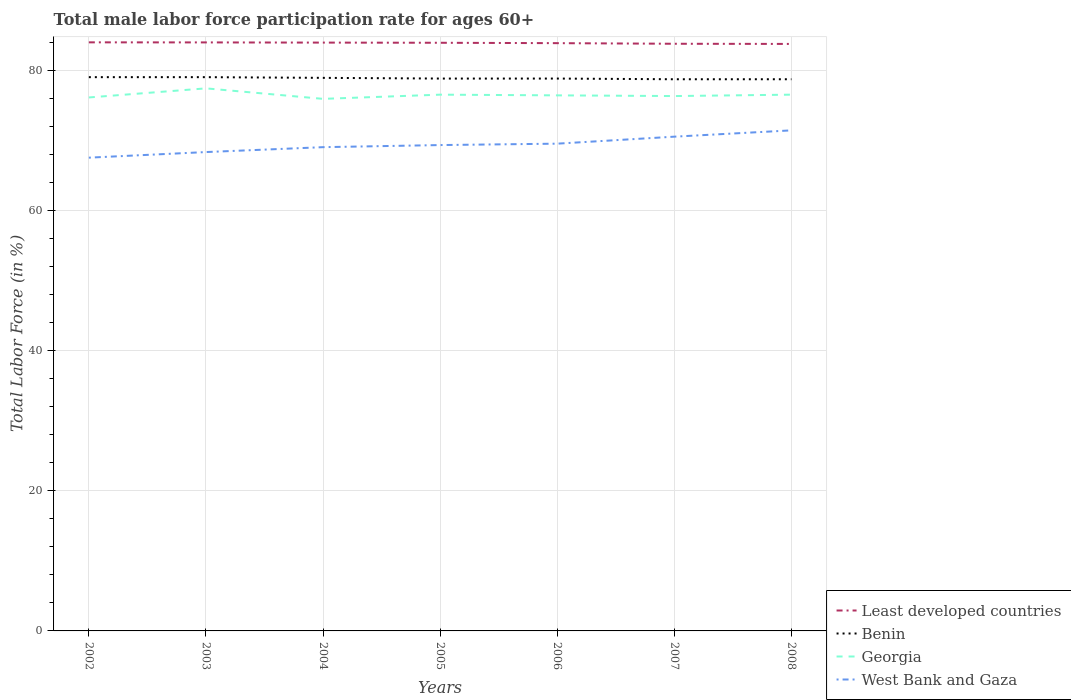Does the line corresponding to Least developed countries intersect with the line corresponding to Georgia?
Ensure brevity in your answer.  No. Across all years, what is the maximum male labor force participation rate in Georgia?
Keep it short and to the point. 76. What is the total male labor force participation rate in Georgia in the graph?
Your answer should be compact. 1.1. What is the difference between the highest and the second highest male labor force participation rate in Least developed countries?
Give a very brief answer. 0.23. What is the difference between the highest and the lowest male labor force participation rate in Georgia?
Your response must be concise. 3. Is the male labor force participation rate in Benin strictly greater than the male labor force participation rate in Least developed countries over the years?
Your answer should be very brief. Yes. How many lines are there?
Provide a short and direct response. 4. What is the difference between two consecutive major ticks on the Y-axis?
Provide a succinct answer. 20. Does the graph contain grids?
Ensure brevity in your answer.  Yes. How are the legend labels stacked?
Offer a very short reply. Vertical. What is the title of the graph?
Keep it short and to the point. Total male labor force participation rate for ages 60+. Does "Netherlands" appear as one of the legend labels in the graph?
Give a very brief answer. No. What is the label or title of the Y-axis?
Provide a succinct answer. Total Labor Force (in %). What is the Total Labor Force (in %) of Least developed countries in 2002?
Your answer should be very brief. 84.07. What is the Total Labor Force (in %) of Benin in 2002?
Your answer should be very brief. 79.1. What is the Total Labor Force (in %) of Georgia in 2002?
Ensure brevity in your answer.  76.2. What is the Total Labor Force (in %) in West Bank and Gaza in 2002?
Your answer should be very brief. 67.6. What is the Total Labor Force (in %) of Least developed countries in 2003?
Your answer should be very brief. 84.06. What is the Total Labor Force (in %) of Benin in 2003?
Your answer should be very brief. 79.1. What is the Total Labor Force (in %) in Georgia in 2003?
Your response must be concise. 77.5. What is the Total Labor Force (in %) in West Bank and Gaza in 2003?
Your response must be concise. 68.4. What is the Total Labor Force (in %) of Least developed countries in 2004?
Offer a terse response. 84.04. What is the Total Labor Force (in %) of Benin in 2004?
Make the answer very short. 79. What is the Total Labor Force (in %) of West Bank and Gaza in 2004?
Give a very brief answer. 69.1. What is the Total Labor Force (in %) in Least developed countries in 2005?
Make the answer very short. 84.01. What is the Total Labor Force (in %) in Benin in 2005?
Ensure brevity in your answer.  78.9. What is the Total Labor Force (in %) of Georgia in 2005?
Your answer should be compact. 76.6. What is the Total Labor Force (in %) in West Bank and Gaza in 2005?
Keep it short and to the point. 69.4. What is the Total Labor Force (in %) in Least developed countries in 2006?
Your answer should be very brief. 83.96. What is the Total Labor Force (in %) in Benin in 2006?
Your answer should be compact. 78.9. What is the Total Labor Force (in %) in Georgia in 2006?
Make the answer very short. 76.5. What is the Total Labor Force (in %) in West Bank and Gaza in 2006?
Give a very brief answer. 69.6. What is the Total Labor Force (in %) of Least developed countries in 2007?
Provide a succinct answer. 83.87. What is the Total Labor Force (in %) of Benin in 2007?
Offer a terse response. 78.8. What is the Total Labor Force (in %) in Georgia in 2007?
Your response must be concise. 76.4. What is the Total Labor Force (in %) of West Bank and Gaza in 2007?
Your answer should be very brief. 70.6. What is the Total Labor Force (in %) in Least developed countries in 2008?
Ensure brevity in your answer.  83.85. What is the Total Labor Force (in %) of Benin in 2008?
Your answer should be compact. 78.8. What is the Total Labor Force (in %) of Georgia in 2008?
Your response must be concise. 76.6. What is the Total Labor Force (in %) of West Bank and Gaza in 2008?
Give a very brief answer. 71.5. Across all years, what is the maximum Total Labor Force (in %) of Least developed countries?
Your answer should be compact. 84.07. Across all years, what is the maximum Total Labor Force (in %) in Benin?
Provide a short and direct response. 79.1. Across all years, what is the maximum Total Labor Force (in %) in Georgia?
Offer a very short reply. 77.5. Across all years, what is the maximum Total Labor Force (in %) in West Bank and Gaza?
Your answer should be very brief. 71.5. Across all years, what is the minimum Total Labor Force (in %) in Least developed countries?
Your answer should be very brief. 83.85. Across all years, what is the minimum Total Labor Force (in %) of Benin?
Provide a short and direct response. 78.8. Across all years, what is the minimum Total Labor Force (in %) in West Bank and Gaza?
Provide a short and direct response. 67.6. What is the total Total Labor Force (in %) in Least developed countries in the graph?
Your response must be concise. 587.86. What is the total Total Labor Force (in %) of Benin in the graph?
Provide a short and direct response. 552.6. What is the total Total Labor Force (in %) of Georgia in the graph?
Give a very brief answer. 535.8. What is the total Total Labor Force (in %) of West Bank and Gaza in the graph?
Keep it short and to the point. 486.2. What is the difference between the Total Labor Force (in %) of Least developed countries in 2002 and that in 2003?
Keep it short and to the point. 0.01. What is the difference between the Total Labor Force (in %) of West Bank and Gaza in 2002 and that in 2003?
Give a very brief answer. -0.8. What is the difference between the Total Labor Force (in %) of Least developed countries in 2002 and that in 2004?
Your answer should be very brief. 0.04. What is the difference between the Total Labor Force (in %) of Benin in 2002 and that in 2004?
Provide a succinct answer. 0.1. What is the difference between the Total Labor Force (in %) of West Bank and Gaza in 2002 and that in 2004?
Give a very brief answer. -1.5. What is the difference between the Total Labor Force (in %) of Least developed countries in 2002 and that in 2005?
Make the answer very short. 0.06. What is the difference between the Total Labor Force (in %) in Benin in 2002 and that in 2005?
Provide a succinct answer. 0.2. What is the difference between the Total Labor Force (in %) in Georgia in 2002 and that in 2005?
Make the answer very short. -0.4. What is the difference between the Total Labor Force (in %) of Least developed countries in 2002 and that in 2006?
Give a very brief answer. 0.12. What is the difference between the Total Labor Force (in %) in Least developed countries in 2002 and that in 2007?
Keep it short and to the point. 0.2. What is the difference between the Total Labor Force (in %) in Benin in 2002 and that in 2007?
Keep it short and to the point. 0.3. What is the difference between the Total Labor Force (in %) of West Bank and Gaza in 2002 and that in 2007?
Keep it short and to the point. -3. What is the difference between the Total Labor Force (in %) in Least developed countries in 2002 and that in 2008?
Give a very brief answer. 0.23. What is the difference between the Total Labor Force (in %) of Benin in 2002 and that in 2008?
Offer a terse response. 0.3. What is the difference between the Total Labor Force (in %) in Georgia in 2002 and that in 2008?
Offer a very short reply. -0.4. What is the difference between the Total Labor Force (in %) of West Bank and Gaza in 2002 and that in 2008?
Keep it short and to the point. -3.9. What is the difference between the Total Labor Force (in %) in Least developed countries in 2003 and that in 2004?
Give a very brief answer. 0.03. What is the difference between the Total Labor Force (in %) in Least developed countries in 2003 and that in 2005?
Give a very brief answer. 0.05. What is the difference between the Total Labor Force (in %) in Benin in 2003 and that in 2005?
Your response must be concise. 0.2. What is the difference between the Total Labor Force (in %) of West Bank and Gaza in 2003 and that in 2005?
Provide a succinct answer. -1. What is the difference between the Total Labor Force (in %) in Least developed countries in 2003 and that in 2006?
Your answer should be very brief. 0.11. What is the difference between the Total Labor Force (in %) of Georgia in 2003 and that in 2006?
Give a very brief answer. 1. What is the difference between the Total Labor Force (in %) of Least developed countries in 2003 and that in 2007?
Give a very brief answer. 0.19. What is the difference between the Total Labor Force (in %) of Least developed countries in 2003 and that in 2008?
Your answer should be compact. 0.22. What is the difference between the Total Labor Force (in %) in Benin in 2003 and that in 2008?
Offer a very short reply. 0.3. What is the difference between the Total Labor Force (in %) of West Bank and Gaza in 2003 and that in 2008?
Your response must be concise. -3.1. What is the difference between the Total Labor Force (in %) in Least developed countries in 2004 and that in 2005?
Make the answer very short. 0.02. What is the difference between the Total Labor Force (in %) in Benin in 2004 and that in 2005?
Give a very brief answer. 0.1. What is the difference between the Total Labor Force (in %) of Georgia in 2004 and that in 2005?
Make the answer very short. -0.6. What is the difference between the Total Labor Force (in %) of West Bank and Gaza in 2004 and that in 2005?
Your answer should be compact. -0.3. What is the difference between the Total Labor Force (in %) of Least developed countries in 2004 and that in 2006?
Offer a very short reply. 0.08. What is the difference between the Total Labor Force (in %) of Benin in 2004 and that in 2006?
Offer a very short reply. 0.1. What is the difference between the Total Labor Force (in %) in Georgia in 2004 and that in 2006?
Provide a succinct answer. -0.5. What is the difference between the Total Labor Force (in %) of West Bank and Gaza in 2004 and that in 2006?
Provide a succinct answer. -0.5. What is the difference between the Total Labor Force (in %) of Least developed countries in 2004 and that in 2007?
Provide a short and direct response. 0.17. What is the difference between the Total Labor Force (in %) of Georgia in 2004 and that in 2007?
Provide a succinct answer. -0.4. What is the difference between the Total Labor Force (in %) of Least developed countries in 2004 and that in 2008?
Offer a terse response. 0.19. What is the difference between the Total Labor Force (in %) of Benin in 2004 and that in 2008?
Give a very brief answer. 0.2. What is the difference between the Total Labor Force (in %) of Least developed countries in 2005 and that in 2006?
Keep it short and to the point. 0.06. What is the difference between the Total Labor Force (in %) of Benin in 2005 and that in 2006?
Offer a terse response. 0. What is the difference between the Total Labor Force (in %) in Georgia in 2005 and that in 2006?
Make the answer very short. 0.1. What is the difference between the Total Labor Force (in %) in Least developed countries in 2005 and that in 2007?
Ensure brevity in your answer.  0.14. What is the difference between the Total Labor Force (in %) of Benin in 2005 and that in 2007?
Your response must be concise. 0.1. What is the difference between the Total Labor Force (in %) in Least developed countries in 2005 and that in 2008?
Make the answer very short. 0.17. What is the difference between the Total Labor Force (in %) in Benin in 2005 and that in 2008?
Provide a short and direct response. 0.1. What is the difference between the Total Labor Force (in %) in West Bank and Gaza in 2005 and that in 2008?
Ensure brevity in your answer.  -2.1. What is the difference between the Total Labor Force (in %) of Least developed countries in 2006 and that in 2007?
Keep it short and to the point. 0.09. What is the difference between the Total Labor Force (in %) in Georgia in 2006 and that in 2007?
Make the answer very short. 0.1. What is the difference between the Total Labor Force (in %) of West Bank and Gaza in 2006 and that in 2007?
Keep it short and to the point. -1. What is the difference between the Total Labor Force (in %) of Least developed countries in 2006 and that in 2008?
Offer a terse response. 0.11. What is the difference between the Total Labor Force (in %) of West Bank and Gaza in 2006 and that in 2008?
Offer a very short reply. -1.9. What is the difference between the Total Labor Force (in %) in Least developed countries in 2007 and that in 2008?
Provide a short and direct response. 0.02. What is the difference between the Total Labor Force (in %) in Least developed countries in 2002 and the Total Labor Force (in %) in Benin in 2003?
Make the answer very short. 4.97. What is the difference between the Total Labor Force (in %) in Least developed countries in 2002 and the Total Labor Force (in %) in Georgia in 2003?
Keep it short and to the point. 6.57. What is the difference between the Total Labor Force (in %) of Least developed countries in 2002 and the Total Labor Force (in %) of West Bank and Gaza in 2003?
Your answer should be compact. 15.67. What is the difference between the Total Labor Force (in %) of Benin in 2002 and the Total Labor Force (in %) of Georgia in 2003?
Provide a short and direct response. 1.6. What is the difference between the Total Labor Force (in %) in Least developed countries in 2002 and the Total Labor Force (in %) in Benin in 2004?
Ensure brevity in your answer.  5.07. What is the difference between the Total Labor Force (in %) of Least developed countries in 2002 and the Total Labor Force (in %) of Georgia in 2004?
Give a very brief answer. 8.07. What is the difference between the Total Labor Force (in %) of Least developed countries in 2002 and the Total Labor Force (in %) of West Bank and Gaza in 2004?
Offer a terse response. 14.97. What is the difference between the Total Labor Force (in %) in Benin in 2002 and the Total Labor Force (in %) in West Bank and Gaza in 2004?
Offer a very short reply. 10. What is the difference between the Total Labor Force (in %) in Least developed countries in 2002 and the Total Labor Force (in %) in Benin in 2005?
Your answer should be compact. 5.17. What is the difference between the Total Labor Force (in %) in Least developed countries in 2002 and the Total Labor Force (in %) in Georgia in 2005?
Keep it short and to the point. 7.47. What is the difference between the Total Labor Force (in %) of Least developed countries in 2002 and the Total Labor Force (in %) of West Bank and Gaza in 2005?
Make the answer very short. 14.67. What is the difference between the Total Labor Force (in %) of Benin in 2002 and the Total Labor Force (in %) of Georgia in 2005?
Offer a very short reply. 2.5. What is the difference between the Total Labor Force (in %) of Benin in 2002 and the Total Labor Force (in %) of West Bank and Gaza in 2005?
Give a very brief answer. 9.7. What is the difference between the Total Labor Force (in %) of Least developed countries in 2002 and the Total Labor Force (in %) of Benin in 2006?
Ensure brevity in your answer.  5.17. What is the difference between the Total Labor Force (in %) of Least developed countries in 2002 and the Total Labor Force (in %) of Georgia in 2006?
Make the answer very short. 7.57. What is the difference between the Total Labor Force (in %) in Least developed countries in 2002 and the Total Labor Force (in %) in West Bank and Gaza in 2006?
Make the answer very short. 14.47. What is the difference between the Total Labor Force (in %) in Benin in 2002 and the Total Labor Force (in %) in West Bank and Gaza in 2006?
Make the answer very short. 9.5. What is the difference between the Total Labor Force (in %) of Georgia in 2002 and the Total Labor Force (in %) of West Bank and Gaza in 2006?
Keep it short and to the point. 6.6. What is the difference between the Total Labor Force (in %) in Least developed countries in 2002 and the Total Labor Force (in %) in Benin in 2007?
Provide a short and direct response. 5.27. What is the difference between the Total Labor Force (in %) of Least developed countries in 2002 and the Total Labor Force (in %) of Georgia in 2007?
Your response must be concise. 7.67. What is the difference between the Total Labor Force (in %) in Least developed countries in 2002 and the Total Labor Force (in %) in West Bank and Gaza in 2007?
Your response must be concise. 13.47. What is the difference between the Total Labor Force (in %) of Least developed countries in 2002 and the Total Labor Force (in %) of Benin in 2008?
Keep it short and to the point. 5.27. What is the difference between the Total Labor Force (in %) of Least developed countries in 2002 and the Total Labor Force (in %) of Georgia in 2008?
Provide a short and direct response. 7.47. What is the difference between the Total Labor Force (in %) in Least developed countries in 2002 and the Total Labor Force (in %) in West Bank and Gaza in 2008?
Keep it short and to the point. 12.57. What is the difference between the Total Labor Force (in %) of Benin in 2002 and the Total Labor Force (in %) of Georgia in 2008?
Offer a terse response. 2.5. What is the difference between the Total Labor Force (in %) in Georgia in 2002 and the Total Labor Force (in %) in West Bank and Gaza in 2008?
Keep it short and to the point. 4.7. What is the difference between the Total Labor Force (in %) of Least developed countries in 2003 and the Total Labor Force (in %) of Benin in 2004?
Make the answer very short. 5.06. What is the difference between the Total Labor Force (in %) of Least developed countries in 2003 and the Total Labor Force (in %) of Georgia in 2004?
Provide a succinct answer. 8.06. What is the difference between the Total Labor Force (in %) of Least developed countries in 2003 and the Total Labor Force (in %) of West Bank and Gaza in 2004?
Make the answer very short. 14.96. What is the difference between the Total Labor Force (in %) of Benin in 2003 and the Total Labor Force (in %) of West Bank and Gaza in 2004?
Offer a very short reply. 10. What is the difference between the Total Labor Force (in %) in Least developed countries in 2003 and the Total Labor Force (in %) in Benin in 2005?
Keep it short and to the point. 5.16. What is the difference between the Total Labor Force (in %) in Least developed countries in 2003 and the Total Labor Force (in %) in Georgia in 2005?
Your response must be concise. 7.46. What is the difference between the Total Labor Force (in %) of Least developed countries in 2003 and the Total Labor Force (in %) of West Bank and Gaza in 2005?
Ensure brevity in your answer.  14.66. What is the difference between the Total Labor Force (in %) of Benin in 2003 and the Total Labor Force (in %) of Georgia in 2005?
Offer a terse response. 2.5. What is the difference between the Total Labor Force (in %) in Georgia in 2003 and the Total Labor Force (in %) in West Bank and Gaza in 2005?
Ensure brevity in your answer.  8.1. What is the difference between the Total Labor Force (in %) of Least developed countries in 2003 and the Total Labor Force (in %) of Benin in 2006?
Ensure brevity in your answer.  5.16. What is the difference between the Total Labor Force (in %) in Least developed countries in 2003 and the Total Labor Force (in %) in Georgia in 2006?
Your answer should be compact. 7.56. What is the difference between the Total Labor Force (in %) of Least developed countries in 2003 and the Total Labor Force (in %) of West Bank and Gaza in 2006?
Ensure brevity in your answer.  14.46. What is the difference between the Total Labor Force (in %) of Georgia in 2003 and the Total Labor Force (in %) of West Bank and Gaza in 2006?
Make the answer very short. 7.9. What is the difference between the Total Labor Force (in %) of Least developed countries in 2003 and the Total Labor Force (in %) of Benin in 2007?
Keep it short and to the point. 5.26. What is the difference between the Total Labor Force (in %) of Least developed countries in 2003 and the Total Labor Force (in %) of Georgia in 2007?
Provide a succinct answer. 7.66. What is the difference between the Total Labor Force (in %) in Least developed countries in 2003 and the Total Labor Force (in %) in West Bank and Gaza in 2007?
Offer a terse response. 13.46. What is the difference between the Total Labor Force (in %) of Benin in 2003 and the Total Labor Force (in %) of Georgia in 2007?
Make the answer very short. 2.7. What is the difference between the Total Labor Force (in %) of Benin in 2003 and the Total Labor Force (in %) of West Bank and Gaza in 2007?
Offer a terse response. 8.5. What is the difference between the Total Labor Force (in %) of Georgia in 2003 and the Total Labor Force (in %) of West Bank and Gaza in 2007?
Your answer should be compact. 6.9. What is the difference between the Total Labor Force (in %) of Least developed countries in 2003 and the Total Labor Force (in %) of Benin in 2008?
Your answer should be very brief. 5.26. What is the difference between the Total Labor Force (in %) in Least developed countries in 2003 and the Total Labor Force (in %) in Georgia in 2008?
Your answer should be compact. 7.46. What is the difference between the Total Labor Force (in %) of Least developed countries in 2003 and the Total Labor Force (in %) of West Bank and Gaza in 2008?
Offer a very short reply. 12.56. What is the difference between the Total Labor Force (in %) in Benin in 2003 and the Total Labor Force (in %) in Georgia in 2008?
Ensure brevity in your answer.  2.5. What is the difference between the Total Labor Force (in %) in Benin in 2003 and the Total Labor Force (in %) in West Bank and Gaza in 2008?
Offer a terse response. 7.6. What is the difference between the Total Labor Force (in %) in Least developed countries in 2004 and the Total Labor Force (in %) in Benin in 2005?
Make the answer very short. 5.14. What is the difference between the Total Labor Force (in %) in Least developed countries in 2004 and the Total Labor Force (in %) in Georgia in 2005?
Your answer should be compact. 7.44. What is the difference between the Total Labor Force (in %) of Least developed countries in 2004 and the Total Labor Force (in %) of West Bank and Gaza in 2005?
Keep it short and to the point. 14.64. What is the difference between the Total Labor Force (in %) in Georgia in 2004 and the Total Labor Force (in %) in West Bank and Gaza in 2005?
Ensure brevity in your answer.  6.6. What is the difference between the Total Labor Force (in %) in Least developed countries in 2004 and the Total Labor Force (in %) in Benin in 2006?
Keep it short and to the point. 5.14. What is the difference between the Total Labor Force (in %) in Least developed countries in 2004 and the Total Labor Force (in %) in Georgia in 2006?
Make the answer very short. 7.54. What is the difference between the Total Labor Force (in %) in Least developed countries in 2004 and the Total Labor Force (in %) in West Bank and Gaza in 2006?
Your response must be concise. 14.44. What is the difference between the Total Labor Force (in %) of Benin in 2004 and the Total Labor Force (in %) of Georgia in 2006?
Make the answer very short. 2.5. What is the difference between the Total Labor Force (in %) in Benin in 2004 and the Total Labor Force (in %) in West Bank and Gaza in 2006?
Offer a very short reply. 9.4. What is the difference between the Total Labor Force (in %) of Least developed countries in 2004 and the Total Labor Force (in %) of Benin in 2007?
Give a very brief answer. 5.24. What is the difference between the Total Labor Force (in %) of Least developed countries in 2004 and the Total Labor Force (in %) of Georgia in 2007?
Your response must be concise. 7.64. What is the difference between the Total Labor Force (in %) in Least developed countries in 2004 and the Total Labor Force (in %) in West Bank and Gaza in 2007?
Make the answer very short. 13.44. What is the difference between the Total Labor Force (in %) in Least developed countries in 2004 and the Total Labor Force (in %) in Benin in 2008?
Ensure brevity in your answer.  5.24. What is the difference between the Total Labor Force (in %) in Least developed countries in 2004 and the Total Labor Force (in %) in Georgia in 2008?
Provide a succinct answer. 7.44. What is the difference between the Total Labor Force (in %) of Least developed countries in 2004 and the Total Labor Force (in %) of West Bank and Gaza in 2008?
Give a very brief answer. 12.54. What is the difference between the Total Labor Force (in %) in Benin in 2004 and the Total Labor Force (in %) in Georgia in 2008?
Your answer should be compact. 2.4. What is the difference between the Total Labor Force (in %) in Least developed countries in 2005 and the Total Labor Force (in %) in Benin in 2006?
Offer a very short reply. 5.11. What is the difference between the Total Labor Force (in %) in Least developed countries in 2005 and the Total Labor Force (in %) in Georgia in 2006?
Provide a short and direct response. 7.51. What is the difference between the Total Labor Force (in %) in Least developed countries in 2005 and the Total Labor Force (in %) in West Bank and Gaza in 2006?
Give a very brief answer. 14.41. What is the difference between the Total Labor Force (in %) of Benin in 2005 and the Total Labor Force (in %) of Georgia in 2006?
Keep it short and to the point. 2.4. What is the difference between the Total Labor Force (in %) in Benin in 2005 and the Total Labor Force (in %) in West Bank and Gaza in 2006?
Keep it short and to the point. 9.3. What is the difference between the Total Labor Force (in %) of Georgia in 2005 and the Total Labor Force (in %) of West Bank and Gaza in 2006?
Provide a short and direct response. 7. What is the difference between the Total Labor Force (in %) of Least developed countries in 2005 and the Total Labor Force (in %) of Benin in 2007?
Your answer should be compact. 5.21. What is the difference between the Total Labor Force (in %) of Least developed countries in 2005 and the Total Labor Force (in %) of Georgia in 2007?
Ensure brevity in your answer.  7.61. What is the difference between the Total Labor Force (in %) of Least developed countries in 2005 and the Total Labor Force (in %) of West Bank and Gaza in 2007?
Offer a very short reply. 13.41. What is the difference between the Total Labor Force (in %) of Benin in 2005 and the Total Labor Force (in %) of West Bank and Gaza in 2007?
Offer a very short reply. 8.3. What is the difference between the Total Labor Force (in %) of Least developed countries in 2005 and the Total Labor Force (in %) of Benin in 2008?
Make the answer very short. 5.21. What is the difference between the Total Labor Force (in %) of Least developed countries in 2005 and the Total Labor Force (in %) of Georgia in 2008?
Keep it short and to the point. 7.41. What is the difference between the Total Labor Force (in %) of Least developed countries in 2005 and the Total Labor Force (in %) of West Bank and Gaza in 2008?
Your answer should be compact. 12.51. What is the difference between the Total Labor Force (in %) of Benin in 2005 and the Total Labor Force (in %) of West Bank and Gaza in 2008?
Your response must be concise. 7.4. What is the difference between the Total Labor Force (in %) in Georgia in 2005 and the Total Labor Force (in %) in West Bank and Gaza in 2008?
Provide a succinct answer. 5.1. What is the difference between the Total Labor Force (in %) of Least developed countries in 2006 and the Total Labor Force (in %) of Benin in 2007?
Offer a terse response. 5.16. What is the difference between the Total Labor Force (in %) in Least developed countries in 2006 and the Total Labor Force (in %) in Georgia in 2007?
Offer a very short reply. 7.56. What is the difference between the Total Labor Force (in %) in Least developed countries in 2006 and the Total Labor Force (in %) in West Bank and Gaza in 2007?
Keep it short and to the point. 13.36. What is the difference between the Total Labor Force (in %) of Benin in 2006 and the Total Labor Force (in %) of West Bank and Gaza in 2007?
Keep it short and to the point. 8.3. What is the difference between the Total Labor Force (in %) of Georgia in 2006 and the Total Labor Force (in %) of West Bank and Gaza in 2007?
Your answer should be compact. 5.9. What is the difference between the Total Labor Force (in %) in Least developed countries in 2006 and the Total Labor Force (in %) in Benin in 2008?
Provide a succinct answer. 5.16. What is the difference between the Total Labor Force (in %) of Least developed countries in 2006 and the Total Labor Force (in %) of Georgia in 2008?
Provide a short and direct response. 7.36. What is the difference between the Total Labor Force (in %) of Least developed countries in 2006 and the Total Labor Force (in %) of West Bank and Gaza in 2008?
Offer a terse response. 12.46. What is the difference between the Total Labor Force (in %) in Benin in 2006 and the Total Labor Force (in %) in West Bank and Gaza in 2008?
Provide a succinct answer. 7.4. What is the difference between the Total Labor Force (in %) in Least developed countries in 2007 and the Total Labor Force (in %) in Benin in 2008?
Provide a short and direct response. 5.07. What is the difference between the Total Labor Force (in %) of Least developed countries in 2007 and the Total Labor Force (in %) of Georgia in 2008?
Your response must be concise. 7.27. What is the difference between the Total Labor Force (in %) of Least developed countries in 2007 and the Total Labor Force (in %) of West Bank and Gaza in 2008?
Make the answer very short. 12.37. What is the difference between the Total Labor Force (in %) in Benin in 2007 and the Total Labor Force (in %) in Georgia in 2008?
Make the answer very short. 2.2. What is the difference between the Total Labor Force (in %) of Benin in 2007 and the Total Labor Force (in %) of West Bank and Gaza in 2008?
Your response must be concise. 7.3. What is the difference between the Total Labor Force (in %) of Georgia in 2007 and the Total Labor Force (in %) of West Bank and Gaza in 2008?
Offer a very short reply. 4.9. What is the average Total Labor Force (in %) of Least developed countries per year?
Your response must be concise. 83.98. What is the average Total Labor Force (in %) of Benin per year?
Your answer should be very brief. 78.94. What is the average Total Labor Force (in %) of Georgia per year?
Offer a terse response. 76.54. What is the average Total Labor Force (in %) of West Bank and Gaza per year?
Make the answer very short. 69.46. In the year 2002, what is the difference between the Total Labor Force (in %) of Least developed countries and Total Labor Force (in %) of Benin?
Your response must be concise. 4.97. In the year 2002, what is the difference between the Total Labor Force (in %) of Least developed countries and Total Labor Force (in %) of Georgia?
Provide a short and direct response. 7.87. In the year 2002, what is the difference between the Total Labor Force (in %) in Least developed countries and Total Labor Force (in %) in West Bank and Gaza?
Make the answer very short. 16.47. In the year 2002, what is the difference between the Total Labor Force (in %) of Benin and Total Labor Force (in %) of Georgia?
Your response must be concise. 2.9. In the year 2002, what is the difference between the Total Labor Force (in %) of Benin and Total Labor Force (in %) of West Bank and Gaza?
Provide a short and direct response. 11.5. In the year 2002, what is the difference between the Total Labor Force (in %) in Georgia and Total Labor Force (in %) in West Bank and Gaza?
Offer a very short reply. 8.6. In the year 2003, what is the difference between the Total Labor Force (in %) of Least developed countries and Total Labor Force (in %) of Benin?
Make the answer very short. 4.96. In the year 2003, what is the difference between the Total Labor Force (in %) in Least developed countries and Total Labor Force (in %) in Georgia?
Offer a very short reply. 6.56. In the year 2003, what is the difference between the Total Labor Force (in %) in Least developed countries and Total Labor Force (in %) in West Bank and Gaza?
Offer a terse response. 15.66. In the year 2003, what is the difference between the Total Labor Force (in %) in Benin and Total Labor Force (in %) in West Bank and Gaza?
Keep it short and to the point. 10.7. In the year 2003, what is the difference between the Total Labor Force (in %) in Georgia and Total Labor Force (in %) in West Bank and Gaza?
Offer a very short reply. 9.1. In the year 2004, what is the difference between the Total Labor Force (in %) of Least developed countries and Total Labor Force (in %) of Benin?
Offer a very short reply. 5.04. In the year 2004, what is the difference between the Total Labor Force (in %) of Least developed countries and Total Labor Force (in %) of Georgia?
Keep it short and to the point. 8.04. In the year 2004, what is the difference between the Total Labor Force (in %) in Least developed countries and Total Labor Force (in %) in West Bank and Gaza?
Ensure brevity in your answer.  14.94. In the year 2004, what is the difference between the Total Labor Force (in %) in Benin and Total Labor Force (in %) in Georgia?
Provide a succinct answer. 3. In the year 2004, what is the difference between the Total Labor Force (in %) of Georgia and Total Labor Force (in %) of West Bank and Gaza?
Offer a terse response. 6.9. In the year 2005, what is the difference between the Total Labor Force (in %) of Least developed countries and Total Labor Force (in %) of Benin?
Provide a succinct answer. 5.11. In the year 2005, what is the difference between the Total Labor Force (in %) of Least developed countries and Total Labor Force (in %) of Georgia?
Provide a succinct answer. 7.41. In the year 2005, what is the difference between the Total Labor Force (in %) of Least developed countries and Total Labor Force (in %) of West Bank and Gaza?
Offer a terse response. 14.61. In the year 2005, what is the difference between the Total Labor Force (in %) in Benin and Total Labor Force (in %) in Georgia?
Provide a succinct answer. 2.3. In the year 2005, what is the difference between the Total Labor Force (in %) in Benin and Total Labor Force (in %) in West Bank and Gaza?
Your response must be concise. 9.5. In the year 2005, what is the difference between the Total Labor Force (in %) of Georgia and Total Labor Force (in %) of West Bank and Gaza?
Provide a short and direct response. 7.2. In the year 2006, what is the difference between the Total Labor Force (in %) in Least developed countries and Total Labor Force (in %) in Benin?
Your answer should be compact. 5.06. In the year 2006, what is the difference between the Total Labor Force (in %) of Least developed countries and Total Labor Force (in %) of Georgia?
Make the answer very short. 7.46. In the year 2006, what is the difference between the Total Labor Force (in %) in Least developed countries and Total Labor Force (in %) in West Bank and Gaza?
Your response must be concise. 14.36. In the year 2006, what is the difference between the Total Labor Force (in %) of Georgia and Total Labor Force (in %) of West Bank and Gaza?
Offer a terse response. 6.9. In the year 2007, what is the difference between the Total Labor Force (in %) of Least developed countries and Total Labor Force (in %) of Benin?
Offer a terse response. 5.07. In the year 2007, what is the difference between the Total Labor Force (in %) in Least developed countries and Total Labor Force (in %) in Georgia?
Your answer should be very brief. 7.47. In the year 2007, what is the difference between the Total Labor Force (in %) of Least developed countries and Total Labor Force (in %) of West Bank and Gaza?
Give a very brief answer. 13.27. In the year 2007, what is the difference between the Total Labor Force (in %) of Benin and Total Labor Force (in %) of West Bank and Gaza?
Your answer should be very brief. 8.2. In the year 2008, what is the difference between the Total Labor Force (in %) in Least developed countries and Total Labor Force (in %) in Benin?
Provide a succinct answer. 5.05. In the year 2008, what is the difference between the Total Labor Force (in %) in Least developed countries and Total Labor Force (in %) in Georgia?
Your answer should be compact. 7.25. In the year 2008, what is the difference between the Total Labor Force (in %) in Least developed countries and Total Labor Force (in %) in West Bank and Gaza?
Your answer should be compact. 12.35. What is the ratio of the Total Labor Force (in %) of Least developed countries in 2002 to that in 2003?
Your answer should be compact. 1. What is the ratio of the Total Labor Force (in %) in Georgia in 2002 to that in 2003?
Give a very brief answer. 0.98. What is the ratio of the Total Labor Force (in %) in West Bank and Gaza in 2002 to that in 2003?
Give a very brief answer. 0.99. What is the ratio of the Total Labor Force (in %) of Least developed countries in 2002 to that in 2004?
Provide a succinct answer. 1. What is the ratio of the Total Labor Force (in %) of Georgia in 2002 to that in 2004?
Ensure brevity in your answer.  1. What is the ratio of the Total Labor Force (in %) of West Bank and Gaza in 2002 to that in 2004?
Ensure brevity in your answer.  0.98. What is the ratio of the Total Labor Force (in %) in Least developed countries in 2002 to that in 2005?
Your response must be concise. 1. What is the ratio of the Total Labor Force (in %) in West Bank and Gaza in 2002 to that in 2005?
Provide a succinct answer. 0.97. What is the ratio of the Total Labor Force (in %) in West Bank and Gaza in 2002 to that in 2006?
Provide a succinct answer. 0.97. What is the ratio of the Total Labor Force (in %) of Georgia in 2002 to that in 2007?
Make the answer very short. 1. What is the ratio of the Total Labor Force (in %) of West Bank and Gaza in 2002 to that in 2007?
Offer a very short reply. 0.96. What is the ratio of the Total Labor Force (in %) of Least developed countries in 2002 to that in 2008?
Keep it short and to the point. 1. What is the ratio of the Total Labor Force (in %) of Benin in 2002 to that in 2008?
Your response must be concise. 1. What is the ratio of the Total Labor Force (in %) of Georgia in 2002 to that in 2008?
Ensure brevity in your answer.  0.99. What is the ratio of the Total Labor Force (in %) in West Bank and Gaza in 2002 to that in 2008?
Keep it short and to the point. 0.95. What is the ratio of the Total Labor Force (in %) of Georgia in 2003 to that in 2004?
Offer a very short reply. 1.02. What is the ratio of the Total Labor Force (in %) of Least developed countries in 2003 to that in 2005?
Your answer should be compact. 1. What is the ratio of the Total Labor Force (in %) in Georgia in 2003 to that in 2005?
Provide a succinct answer. 1.01. What is the ratio of the Total Labor Force (in %) of West Bank and Gaza in 2003 to that in 2005?
Offer a terse response. 0.99. What is the ratio of the Total Labor Force (in %) in Georgia in 2003 to that in 2006?
Provide a succinct answer. 1.01. What is the ratio of the Total Labor Force (in %) in West Bank and Gaza in 2003 to that in 2006?
Your answer should be very brief. 0.98. What is the ratio of the Total Labor Force (in %) in Least developed countries in 2003 to that in 2007?
Offer a terse response. 1. What is the ratio of the Total Labor Force (in %) in Georgia in 2003 to that in 2007?
Keep it short and to the point. 1.01. What is the ratio of the Total Labor Force (in %) of West Bank and Gaza in 2003 to that in 2007?
Offer a terse response. 0.97. What is the ratio of the Total Labor Force (in %) in Benin in 2003 to that in 2008?
Provide a succinct answer. 1. What is the ratio of the Total Labor Force (in %) in Georgia in 2003 to that in 2008?
Keep it short and to the point. 1.01. What is the ratio of the Total Labor Force (in %) in West Bank and Gaza in 2003 to that in 2008?
Make the answer very short. 0.96. What is the ratio of the Total Labor Force (in %) in Least developed countries in 2004 to that in 2005?
Make the answer very short. 1. What is the ratio of the Total Labor Force (in %) of Benin in 2004 to that in 2005?
Your answer should be compact. 1. What is the ratio of the Total Labor Force (in %) in West Bank and Gaza in 2004 to that in 2005?
Provide a short and direct response. 1. What is the ratio of the Total Labor Force (in %) in Least developed countries in 2004 to that in 2006?
Provide a succinct answer. 1. What is the ratio of the Total Labor Force (in %) of Least developed countries in 2004 to that in 2007?
Make the answer very short. 1. What is the ratio of the Total Labor Force (in %) in Benin in 2004 to that in 2007?
Your answer should be very brief. 1. What is the ratio of the Total Labor Force (in %) of West Bank and Gaza in 2004 to that in 2007?
Offer a terse response. 0.98. What is the ratio of the Total Labor Force (in %) in Least developed countries in 2004 to that in 2008?
Ensure brevity in your answer.  1. What is the ratio of the Total Labor Force (in %) in West Bank and Gaza in 2004 to that in 2008?
Ensure brevity in your answer.  0.97. What is the ratio of the Total Labor Force (in %) in Least developed countries in 2005 to that in 2006?
Offer a terse response. 1. What is the ratio of the Total Labor Force (in %) of Georgia in 2005 to that in 2006?
Keep it short and to the point. 1. What is the ratio of the Total Labor Force (in %) of West Bank and Gaza in 2005 to that in 2006?
Provide a short and direct response. 1. What is the ratio of the Total Labor Force (in %) of Least developed countries in 2005 to that in 2007?
Offer a terse response. 1. What is the ratio of the Total Labor Force (in %) in Benin in 2005 to that in 2007?
Offer a very short reply. 1. What is the ratio of the Total Labor Force (in %) of Georgia in 2005 to that in 2007?
Provide a short and direct response. 1. What is the ratio of the Total Labor Force (in %) of Benin in 2005 to that in 2008?
Your response must be concise. 1. What is the ratio of the Total Labor Force (in %) in West Bank and Gaza in 2005 to that in 2008?
Give a very brief answer. 0.97. What is the ratio of the Total Labor Force (in %) in Least developed countries in 2006 to that in 2007?
Your response must be concise. 1. What is the ratio of the Total Labor Force (in %) of Benin in 2006 to that in 2007?
Your answer should be very brief. 1. What is the ratio of the Total Labor Force (in %) of Georgia in 2006 to that in 2007?
Ensure brevity in your answer.  1. What is the ratio of the Total Labor Force (in %) of West Bank and Gaza in 2006 to that in 2007?
Your answer should be compact. 0.99. What is the ratio of the Total Labor Force (in %) of West Bank and Gaza in 2006 to that in 2008?
Offer a very short reply. 0.97. What is the ratio of the Total Labor Force (in %) in West Bank and Gaza in 2007 to that in 2008?
Your response must be concise. 0.99. What is the difference between the highest and the second highest Total Labor Force (in %) of Least developed countries?
Offer a very short reply. 0.01. What is the difference between the highest and the second highest Total Labor Force (in %) in Benin?
Give a very brief answer. 0. What is the difference between the highest and the lowest Total Labor Force (in %) of Least developed countries?
Offer a terse response. 0.23. 